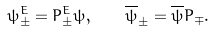Convert formula to latex. <formula><loc_0><loc_0><loc_500><loc_500>\psi ^ { E } _ { \pm } = P ^ { E } _ { \pm } \psi , \quad \overline { \psi } _ { \pm } = \overline { \psi } P _ { \mp } .</formula> 